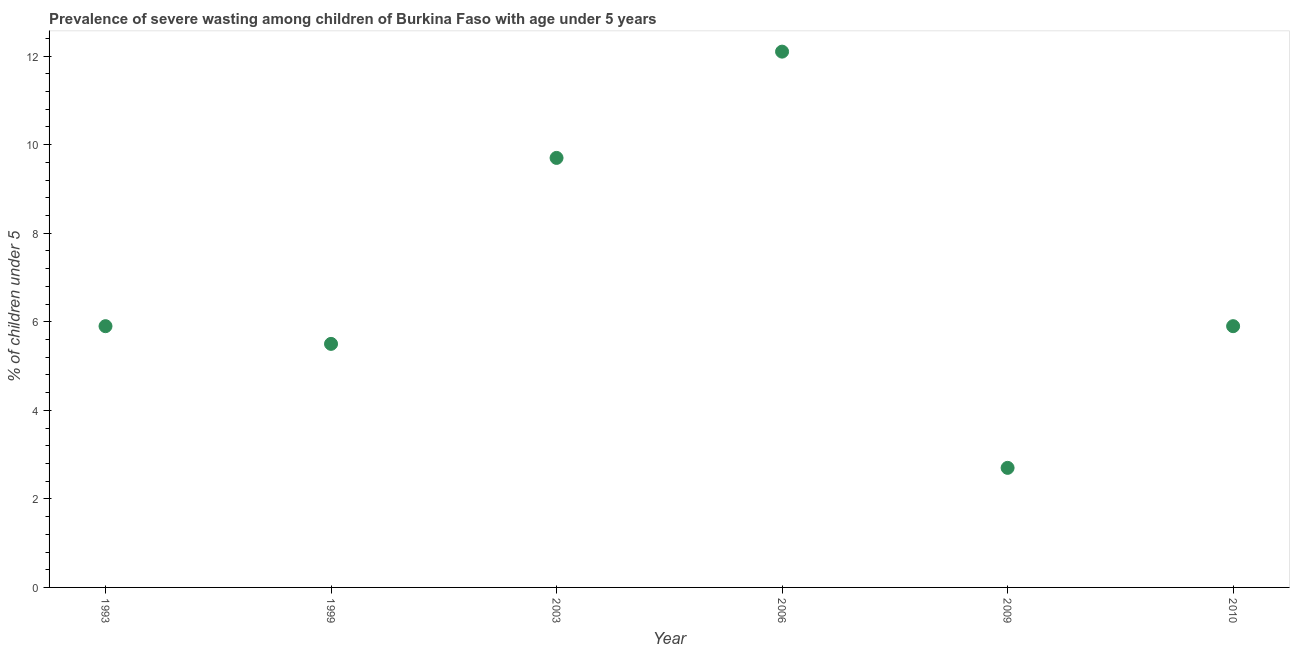What is the prevalence of severe wasting in 2003?
Provide a succinct answer. 9.7. Across all years, what is the maximum prevalence of severe wasting?
Offer a terse response. 12.1. Across all years, what is the minimum prevalence of severe wasting?
Your answer should be very brief. 2.7. What is the sum of the prevalence of severe wasting?
Give a very brief answer. 41.8. What is the difference between the prevalence of severe wasting in 1999 and 2003?
Give a very brief answer. -4.2. What is the average prevalence of severe wasting per year?
Your response must be concise. 6.97. What is the median prevalence of severe wasting?
Your answer should be compact. 5.9. Do a majority of the years between 2003 and 1999 (inclusive) have prevalence of severe wasting greater than 6.4 %?
Offer a terse response. No. What is the ratio of the prevalence of severe wasting in 1993 to that in 2009?
Your answer should be compact. 2.19. Is the prevalence of severe wasting in 1993 less than that in 1999?
Provide a short and direct response. No. Is the difference between the prevalence of severe wasting in 2006 and 2010 greater than the difference between any two years?
Offer a very short reply. No. What is the difference between the highest and the second highest prevalence of severe wasting?
Keep it short and to the point. 2.4. What is the difference between the highest and the lowest prevalence of severe wasting?
Your answer should be compact. 9.4. In how many years, is the prevalence of severe wasting greater than the average prevalence of severe wasting taken over all years?
Provide a succinct answer. 2. Does the prevalence of severe wasting monotonically increase over the years?
Make the answer very short. No. How many dotlines are there?
Make the answer very short. 1. Does the graph contain any zero values?
Keep it short and to the point. No. Does the graph contain grids?
Your answer should be very brief. No. What is the title of the graph?
Provide a short and direct response. Prevalence of severe wasting among children of Burkina Faso with age under 5 years. What is the label or title of the Y-axis?
Offer a very short reply.  % of children under 5. What is the  % of children under 5 in 1993?
Offer a terse response. 5.9. What is the  % of children under 5 in 1999?
Give a very brief answer. 5.5. What is the  % of children under 5 in 2003?
Your response must be concise. 9.7. What is the  % of children under 5 in 2006?
Your response must be concise. 12.1. What is the  % of children under 5 in 2009?
Provide a succinct answer. 2.7. What is the  % of children under 5 in 2010?
Make the answer very short. 5.9. What is the difference between the  % of children under 5 in 1993 and 2009?
Your response must be concise. 3.2. What is the difference between the  % of children under 5 in 1999 and 2003?
Provide a succinct answer. -4.2. What is the difference between the  % of children under 5 in 1999 and 2006?
Your answer should be very brief. -6.6. What is the difference between the  % of children under 5 in 2003 and 2009?
Your answer should be compact. 7. What is the difference between the  % of children under 5 in 2006 and 2010?
Keep it short and to the point. 6.2. What is the ratio of the  % of children under 5 in 1993 to that in 1999?
Your answer should be compact. 1.07. What is the ratio of the  % of children under 5 in 1993 to that in 2003?
Provide a short and direct response. 0.61. What is the ratio of the  % of children under 5 in 1993 to that in 2006?
Ensure brevity in your answer.  0.49. What is the ratio of the  % of children under 5 in 1993 to that in 2009?
Your response must be concise. 2.19. What is the ratio of the  % of children under 5 in 1999 to that in 2003?
Provide a short and direct response. 0.57. What is the ratio of the  % of children under 5 in 1999 to that in 2006?
Keep it short and to the point. 0.46. What is the ratio of the  % of children under 5 in 1999 to that in 2009?
Give a very brief answer. 2.04. What is the ratio of the  % of children under 5 in 1999 to that in 2010?
Give a very brief answer. 0.93. What is the ratio of the  % of children under 5 in 2003 to that in 2006?
Your answer should be very brief. 0.8. What is the ratio of the  % of children under 5 in 2003 to that in 2009?
Make the answer very short. 3.59. What is the ratio of the  % of children under 5 in 2003 to that in 2010?
Keep it short and to the point. 1.64. What is the ratio of the  % of children under 5 in 2006 to that in 2009?
Ensure brevity in your answer.  4.48. What is the ratio of the  % of children under 5 in 2006 to that in 2010?
Your answer should be very brief. 2.05. What is the ratio of the  % of children under 5 in 2009 to that in 2010?
Your answer should be very brief. 0.46. 